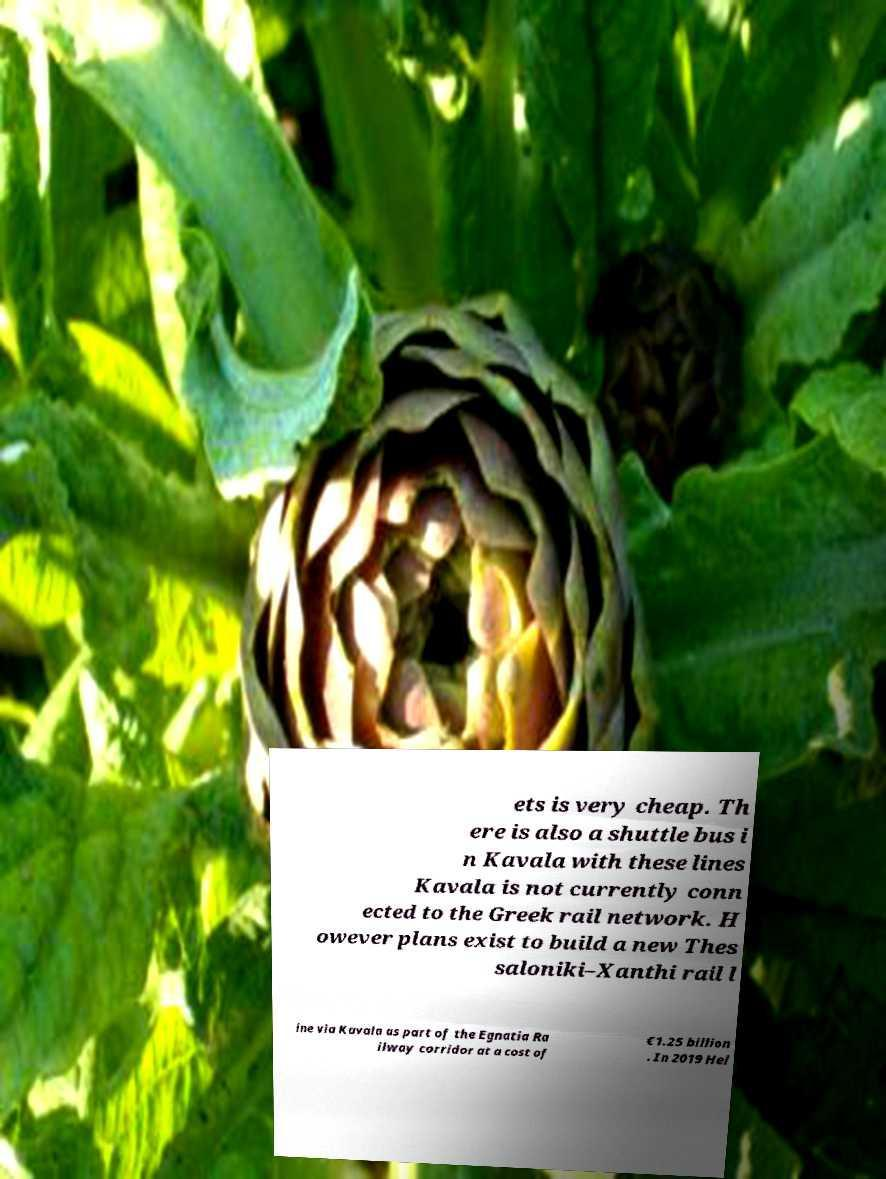Please read and relay the text visible in this image. What does it say? ets is very cheap. Th ere is also a shuttle bus i n Kavala with these lines Kavala is not currently conn ected to the Greek rail network. H owever plans exist to build a new Thes saloniki–Xanthi rail l ine via Kavala as part of the Egnatia Ra ilway corridor at a cost of €1.25 billion . In 2019 Hel 